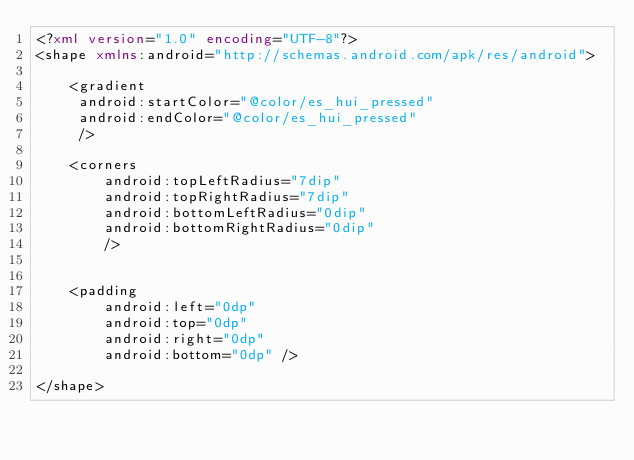<code> <loc_0><loc_0><loc_500><loc_500><_XML_><?xml version="1.0" encoding="UTF-8"?> 
<shape xmlns:android="http://schemas.android.com/apk/res/android"> 

    <gradient
     android:startColor="@color/es_hui_pressed"
     android:endColor="@color/es_hui_pressed"
     />
         
    <corners
        android:topLeftRadius="7dip"
        android:topRightRadius="7dip"
        android:bottomLeftRadius="0dip"
        android:bottomRightRadius="0dip"
        />


    <padding
        android:left="0dp"
        android:top="0dp"
        android:right="0dp"
        android:bottom="0dp" />

</shape>
</code> 